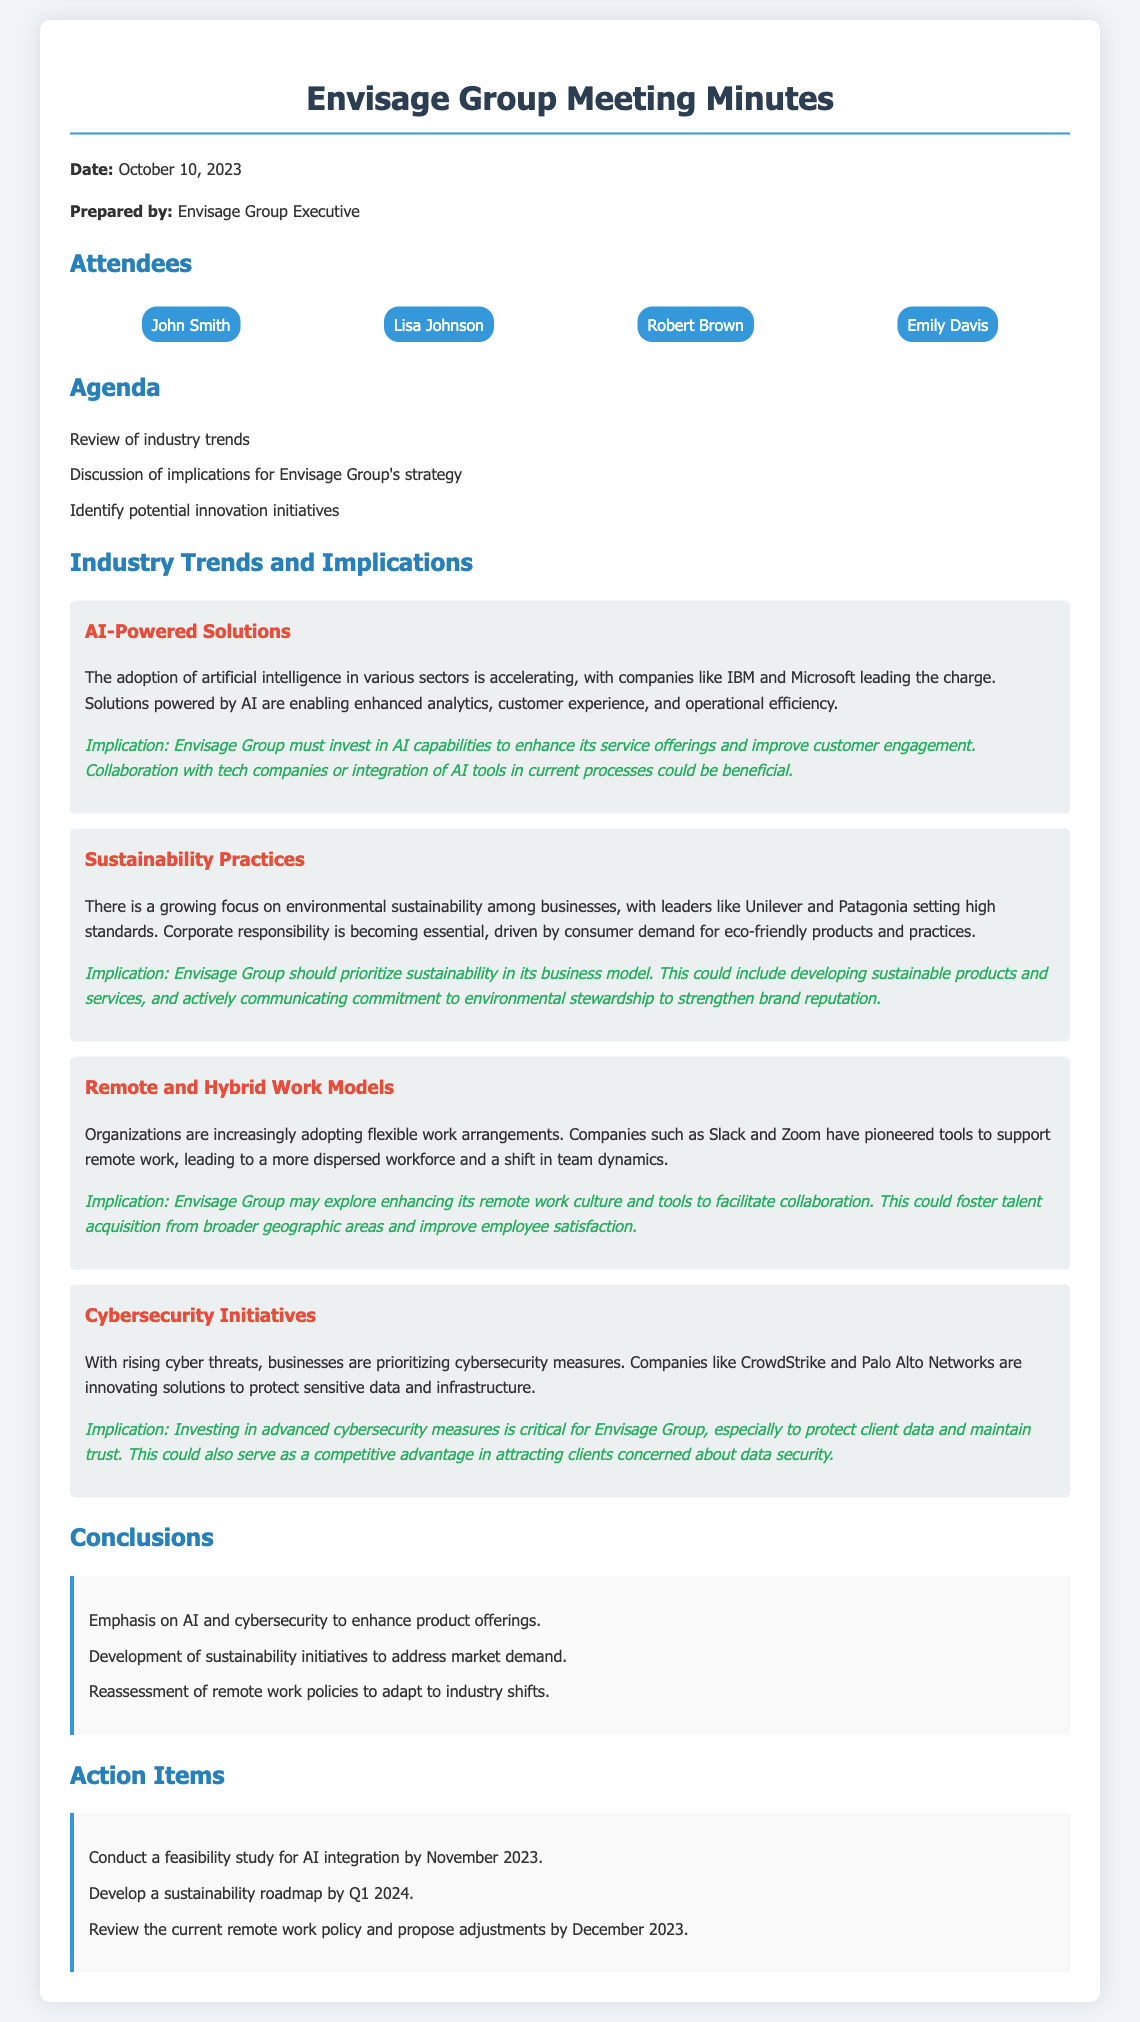What is the date of the meeting? The date of the meeting is stated in the introduction section of the minutes.
Answer: October 10, 2023 Who prepared the meeting minutes? The minutes indicate the individual responsible for preparation.
Answer: Envisage Group Executive What is one of the agenda items? The agenda outlines key topics discussed during the meeting.
Answer: Discussion of implications for Envisage Group's strategy What trend is mentioned first in the document? The trends are listed in the order they appear in the document.
Answer: AI-Powered Solutions Which company is highlighted for leading in AI adoption? The document specifies a company recognized for its advancements in AI.
Answer: IBM What implication is associated with sustainability practices? The implications section outlines suggestions based on industry trends.
Answer: Envisage Group should prioritize sustainability in its business model What is one action item listed for November 2023? The action items detail specific tasks with deadlines following the meeting.
Answer: Conduct a feasibility study for AI integration How many attendees are listed in the minutes? The list of attendees provides the number of participants in the meeting.
Answer: Four What color is used for the implication text? The color used for the implications is noted in the style of the document.
Answer: Green What is the overall theme of the conclusions? The conclusions summarise the strategic directions identified in the meeting.
Answer: Emphasis on AI and cybersecurity to enhance product offerings 